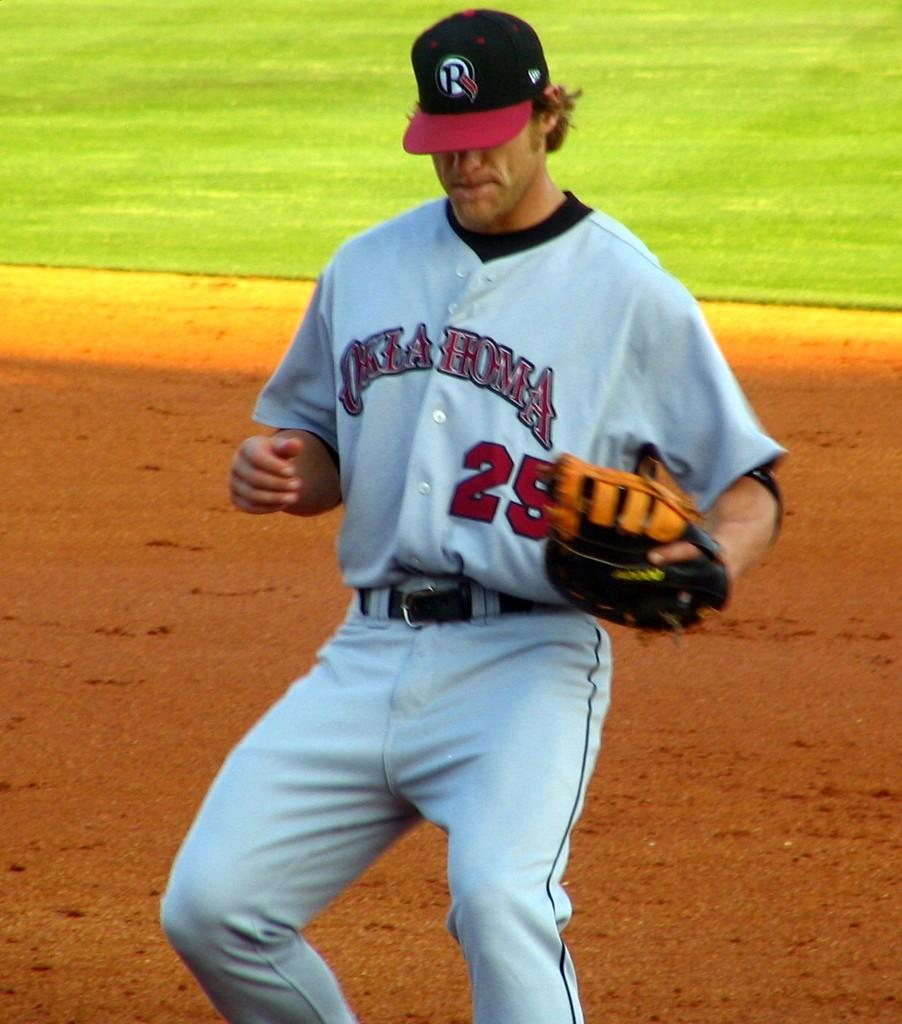<image>
Describe the image concisely. An Oklahoma baseball player wearing number 25 moves gingerly across the dirt. 